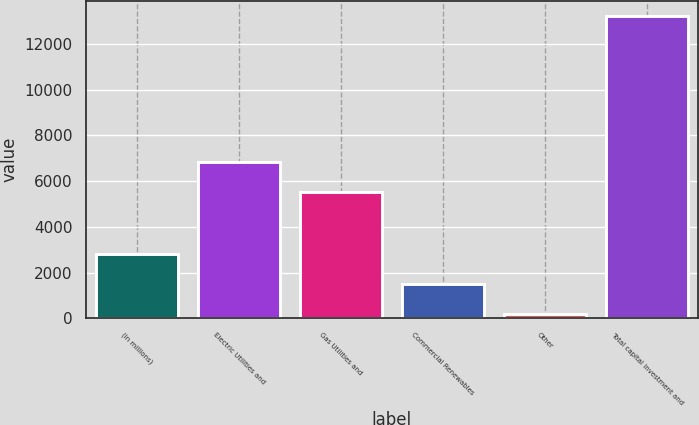Convert chart. <chart><loc_0><loc_0><loc_500><loc_500><bar_chart><fcel>(in millions)<fcel>Electric Utilities and<fcel>Gas Utilities and<fcel>Commercial Renewables<fcel>Other<fcel>Total capital investment and<nl><fcel>2795<fcel>6821.5<fcel>5519<fcel>1492.5<fcel>190<fcel>13215<nl></chart> 